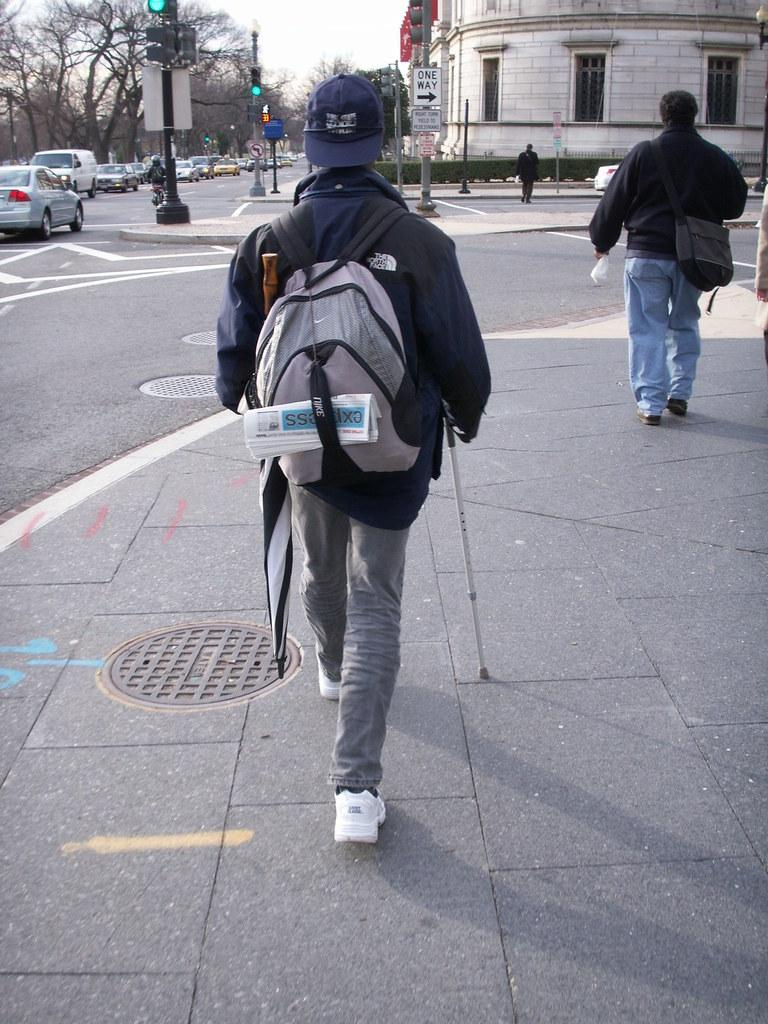What are the two persons in the image doing? The two persons in the image are walking. What are the persons carrying on their backs? The persons are wearing bags. What can be seen in the background of the image? There is a tree, the sky, and a building visible in the image. What is present on the road in the image? Vehicles are present on the road in the image. What is attached to the pole in the image? There is a traffic signal with a pole in the image. Can you describe the clothing of one of the persons? One person is wearing a cap. What type of knot is being tied by the fireman in the image? There is no fireman or knot present in the image. Is the person wearing a mask in the image? There is no person wearing a mask in the image. 